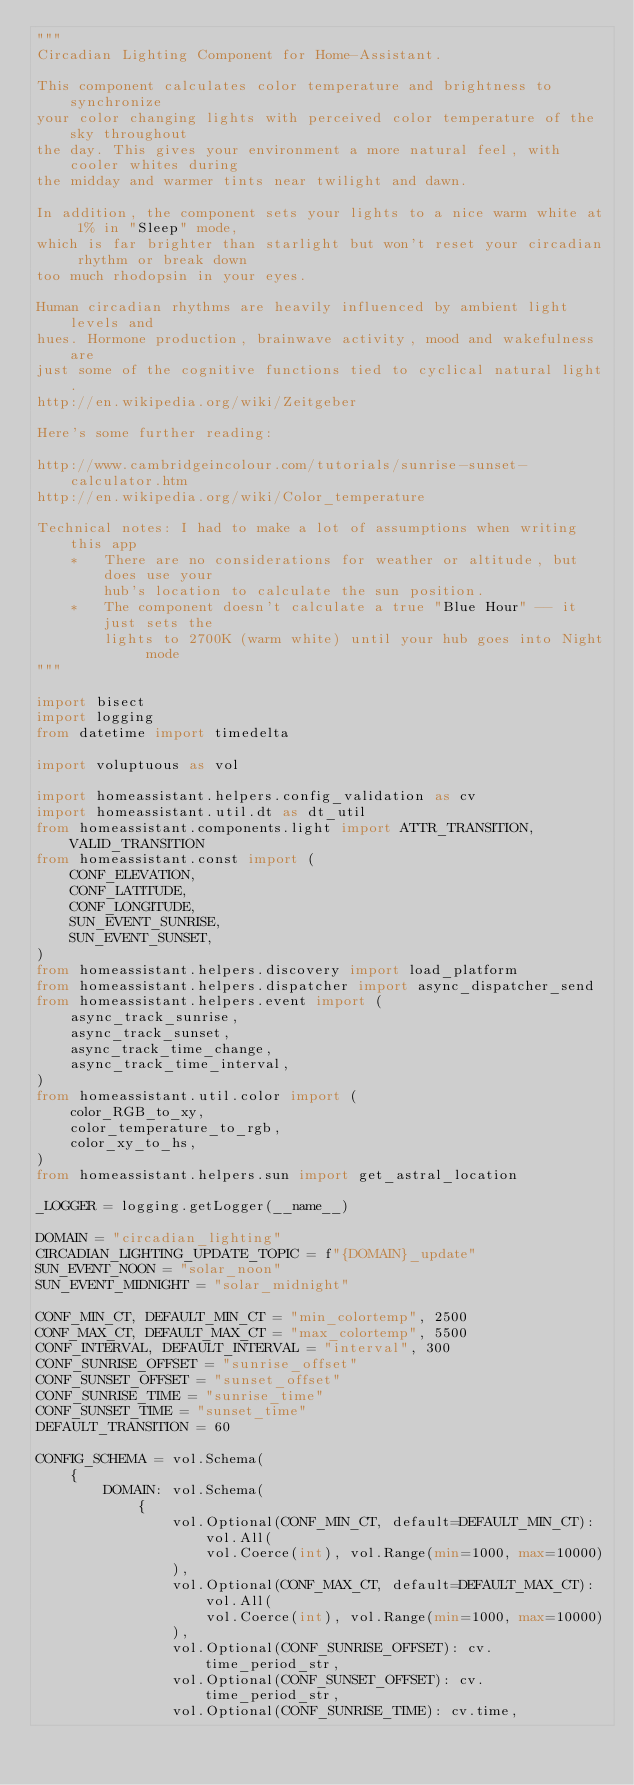Convert code to text. <code><loc_0><loc_0><loc_500><loc_500><_Python_>"""
Circadian Lighting Component for Home-Assistant.

This component calculates color temperature and brightness to synchronize
your color changing lights with perceived color temperature of the sky throughout
the day. This gives your environment a more natural feel, with cooler whites during
the midday and warmer tints near twilight and dawn.

In addition, the component sets your lights to a nice warm white at 1% in "Sleep" mode,
which is far brighter than starlight but won't reset your circadian rhythm or break down
too much rhodopsin in your eyes.

Human circadian rhythms are heavily influenced by ambient light levels and
hues. Hormone production, brainwave activity, mood and wakefulness are
just some of the cognitive functions tied to cyclical natural light.
http://en.wikipedia.org/wiki/Zeitgeber

Here's some further reading:

http://www.cambridgeincolour.com/tutorials/sunrise-sunset-calculator.htm
http://en.wikipedia.org/wiki/Color_temperature

Technical notes: I had to make a lot of assumptions when writing this app
    *   There are no considerations for weather or altitude, but does use your
        hub's location to calculate the sun position.
    *   The component doesn't calculate a true "Blue Hour" -- it just sets the
        lights to 2700K (warm white) until your hub goes into Night mode
"""

import bisect
import logging
from datetime import timedelta

import voluptuous as vol

import homeassistant.helpers.config_validation as cv
import homeassistant.util.dt as dt_util
from homeassistant.components.light import ATTR_TRANSITION, VALID_TRANSITION
from homeassistant.const import (
    CONF_ELEVATION,
    CONF_LATITUDE,
    CONF_LONGITUDE,
    SUN_EVENT_SUNRISE,
    SUN_EVENT_SUNSET,
)
from homeassistant.helpers.discovery import load_platform
from homeassistant.helpers.dispatcher import async_dispatcher_send
from homeassistant.helpers.event import (
    async_track_sunrise,
    async_track_sunset,
    async_track_time_change,
    async_track_time_interval,
)
from homeassistant.util.color import (
    color_RGB_to_xy,
    color_temperature_to_rgb,
    color_xy_to_hs,
)
from homeassistant.helpers.sun import get_astral_location

_LOGGER = logging.getLogger(__name__)

DOMAIN = "circadian_lighting"
CIRCADIAN_LIGHTING_UPDATE_TOPIC = f"{DOMAIN}_update"
SUN_EVENT_NOON = "solar_noon"
SUN_EVENT_MIDNIGHT = "solar_midnight"

CONF_MIN_CT, DEFAULT_MIN_CT = "min_colortemp", 2500
CONF_MAX_CT, DEFAULT_MAX_CT = "max_colortemp", 5500
CONF_INTERVAL, DEFAULT_INTERVAL = "interval", 300
CONF_SUNRISE_OFFSET = "sunrise_offset"
CONF_SUNSET_OFFSET = "sunset_offset"
CONF_SUNRISE_TIME = "sunrise_time"
CONF_SUNSET_TIME = "sunset_time"
DEFAULT_TRANSITION = 60

CONFIG_SCHEMA = vol.Schema(
    {
        DOMAIN: vol.Schema(
            {
                vol.Optional(CONF_MIN_CT, default=DEFAULT_MIN_CT): vol.All(
                    vol.Coerce(int), vol.Range(min=1000, max=10000)
                ),
                vol.Optional(CONF_MAX_CT, default=DEFAULT_MAX_CT): vol.All(
                    vol.Coerce(int), vol.Range(min=1000, max=10000)
                ),
                vol.Optional(CONF_SUNRISE_OFFSET): cv.time_period_str,
                vol.Optional(CONF_SUNSET_OFFSET): cv.time_period_str,
                vol.Optional(CONF_SUNRISE_TIME): cv.time,</code> 